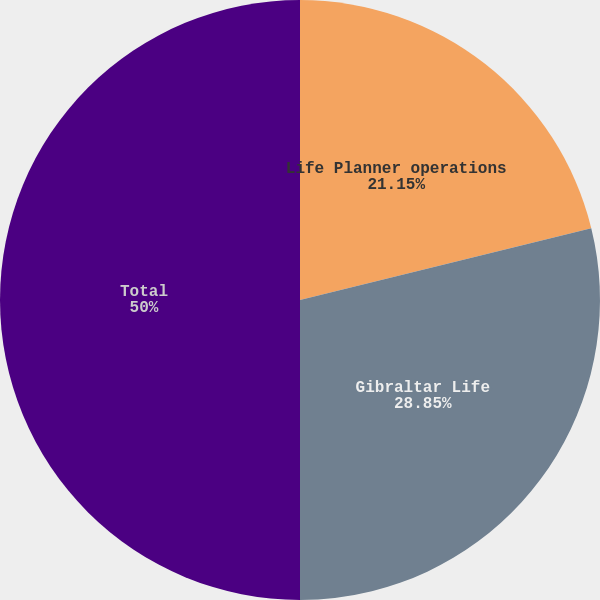<chart> <loc_0><loc_0><loc_500><loc_500><pie_chart><fcel>Life Planner operations<fcel>Gibraltar Life<fcel>Total<nl><fcel>21.15%<fcel>28.85%<fcel>50.0%<nl></chart> 